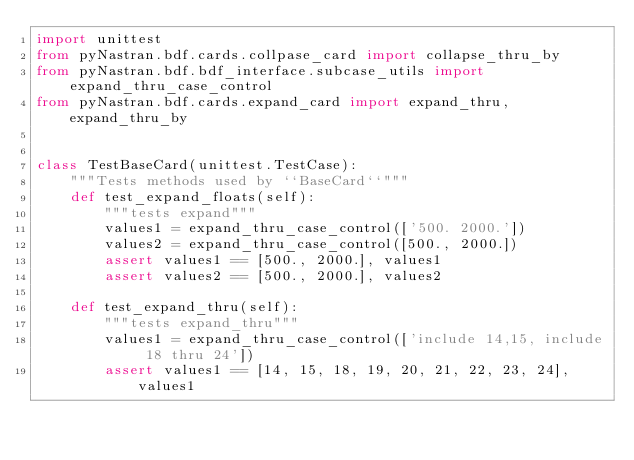<code> <loc_0><loc_0><loc_500><loc_500><_Python_>import unittest
from pyNastran.bdf.cards.collpase_card import collapse_thru_by
from pyNastran.bdf.bdf_interface.subcase_utils import expand_thru_case_control
from pyNastran.bdf.cards.expand_card import expand_thru, expand_thru_by


class TestBaseCard(unittest.TestCase):
    """Tests methods used by ``BaseCard``"""
    def test_expand_floats(self):
        """tests expand"""
        values1 = expand_thru_case_control(['500. 2000.'])
        values2 = expand_thru_case_control([500., 2000.])
        assert values1 == [500., 2000.], values1
        assert values2 == [500., 2000.], values2

    def test_expand_thru(self):
        """tests expand_thru"""
        values1 = expand_thru_case_control(['include 14,15, include 18 thru 24'])
        assert values1 == [14, 15, 18, 19, 20, 21, 22, 23, 24], values1
</code> 